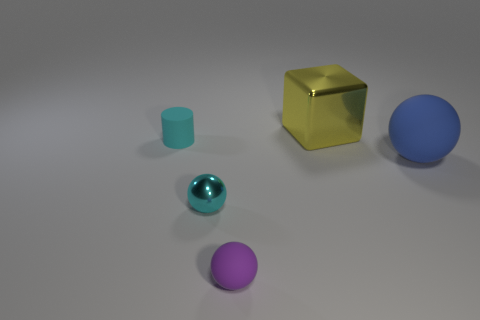There is another object that is the same material as the yellow thing; what size is it?
Provide a short and direct response. Small. What number of objects are matte objects that are to the left of the large blue rubber thing or large gray rubber spheres?
Ensure brevity in your answer.  2. There is a big matte ball that is behind the cyan metallic thing; is its color the same as the tiny metallic sphere?
Make the answer very short. No. The purple rubber thing that is the same shape as the big blue object is what size?
Your answer should be very brief. Small. What is the color of the shiny thing that is on the left side of the metal thing that is behind the tiny matte thing to the left of the small cyan metallic ball?
Offer a very short reply. Cyan. Is the big yellow thing made of the same material as the small purple object?
Offer a terse response. No. Is there a tiny shiny ball that is right of the small object in front of the shiny object that is left of the large yellow thing?
Offer a terse response. No. Is the color of the big matte ball the same as the metallic ball?
Keep it short and to the point. No. Is the number of large balls less than the number of small rubber cubes?
Provide a succinct answer. No. Is the material of the big object left of the big blue rubber object the same as the small object that is behind the small cyan metal sphere?
Keep it short and to the point. No. 